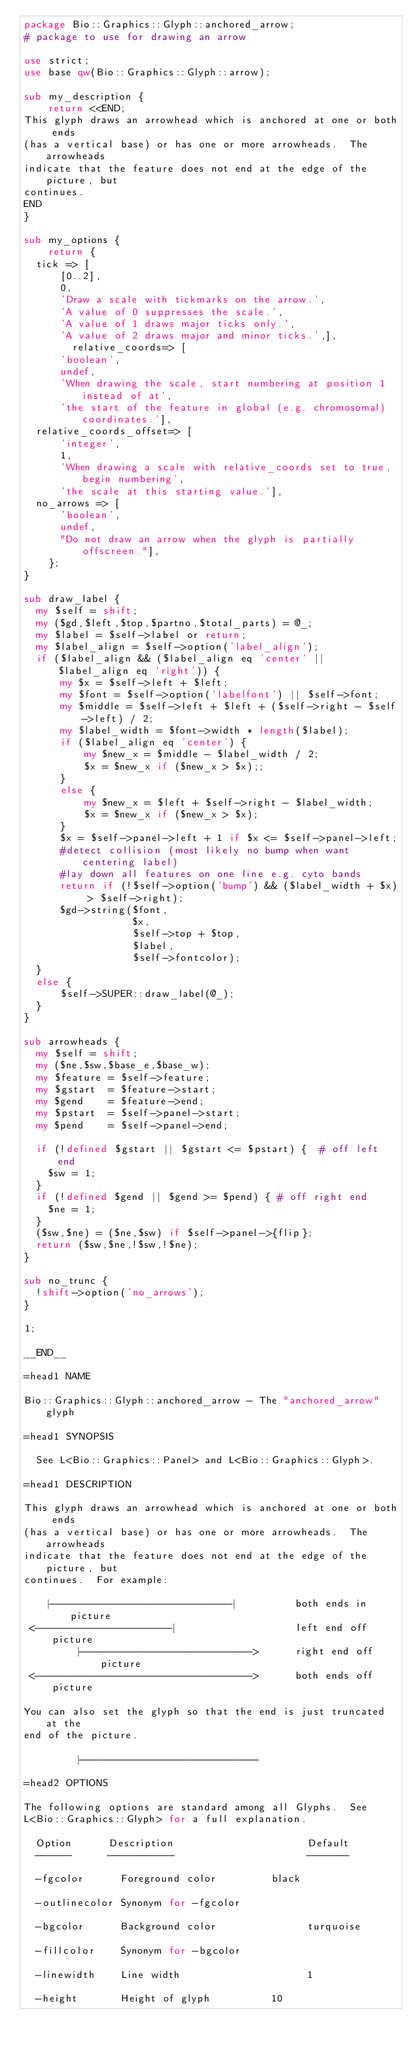Convert code to text. <code><loc_0><loc_0><loc_500><loc_500><_Perl_>package Bio::Graphics::Glyph::anchored_arrow;
# package to use for drawing an arrow

use strict;
use base qw(Bio::Graphics::Glyph::arrow);

sub my_description {
    return <<END;
This glyph draws an arrowhead which is anchored at one or both ends
(has a vertical base) or has one or more arrowheads.  The arrowheads
indicate that the feature does not end at the edge of the picture, but
continues.
END
}

sub my_options {
    return {
	tick => [
	    [0..2],
	    0,
	    'Draw a scale with tickmarks on the arrow.',
	    'A value of 0 suppresses the scale.',
	    'A value of 1 draws major ticks only.',
	    'A value of 2 draws major and minor ticks.',],
        relative_coords=> [
	    'boolean',
	    undef,
	    'When drawing the scale, start numbering at position 1 instead of at',
	    'the start of the feature in global (e.g. chromosomal) coordinates.'],
	relative_coords_offset=> [
	    'integer',
	    1,
	    'When drawing a scale with relative_coords set to true, begin numbering',
	    'the scale at this starting value.'],
	no_arrows => [
	    'boolean',
	    undef,
	    "Do not draw an arrow when the glyph is partially offscreen."],
    };
}

sub draw_label {
  my $self = shift;
  my ($gd,$left,$top,$partno,$total_parts) = @_;
  my $label = $self->label or return;
  my $label_align = $self->option('label_align');
  if ($label_align && ($label_align eq 'center' || $label_align eq 'right')) {
      my $x = $self->left + $left;
      my $font = $self->option('labelfont') || $self->font;
      my $middle = $self->left + $left + ($self->right - $self->left) / 2;
      my $label_width = $font->width * length($label);
      if ($label_align eq 'center') {
          my $new_x = $middle - $label_width / 2;
          $x = $new_x if ($new_x > $x);;
      }
      else {
          my $new_x = $left + $self->right - $label_width;
          $x = $new_x if ($new_x > $x);
      }
      $x = $self->panel->left + 1 if $x <= $self->panel->left;
      #detect collision (most likely no bump when want centering label)
      #lay down all features on one line e.g. cyto bands
      return if (!$self->option('bump') && ($label_width + $x) > $self->right);
      $gd->string($font,
                  $x,
                  $self->top + $top,
                  $label,
                  $self->fontcolor);
  }
  else {
      $self->SUPER::draw_label(@_);
  }
}

sub arrowheads {
  my $self = shift;
  my ($ne,$sw,$base_e,$base_w);
  my $feature = $self->feature;
  my $gstart  = $feature->start;
  my $gend    = $feature->end;
  my $pstart  = $self->panel->start;
  my $pend    = $self->panel->end;

  if (!defined $gstart || $gstart <= $pstart) {  # off left end
    $sw = 1;
  }
  if (!defined $gend || $gend >= $pend) { # off right end
    $ne = 1;
  }
  ($sw,$ne) = ($ne,$sw) if $self->panel->{flip};
  return ($sw,$ne,!$sw,!$ne);
}

sub no_trunc {
  !shift->option('no_arrows');
}

1;

__END__

=head1 NAME

Bio::Graphics::Glyph::anchored_arrow - The "anchored_arrow" glyph

=head1 SYNOPSIS

  See L<Bio::Graphics::Panel> and L<Bio::Graphics::Glyph>.

=head1 DESCRIPTION

This glyph draws an arrowhead which is anchored at one or both ends
(has a vertical base) or has one or more arrowheads.  The arrowheads
indicate that the feature does not end at the edge of the picture, but
continues.  For example:

    |-----------------------------|          both ends in picture
 <----------------------|                    left end off picture
         |---------------------------->      right end off picture
 <------------------------------------>      both ends off picture

You can also set the glyph so that the end is just truncated at the
end of the picture.

         |-----------------------------

=head2 OPTIONS

The following options are standard among all Glyphs.  See
L<Bio::Graphics::Glyph> for a full explanation.

  Option      Description                      Default
  ------      -----------                      -------

  -fgcolor      Foreground color	       black

  -outlinecolor	Synonym for -fgcolor

  -bgcolor      Background color               turquoise

  -fillcolor    Synonym for -bgcolor

  -linewidth    Line width                     1

  -height       Height of glyph		       10
</code> 